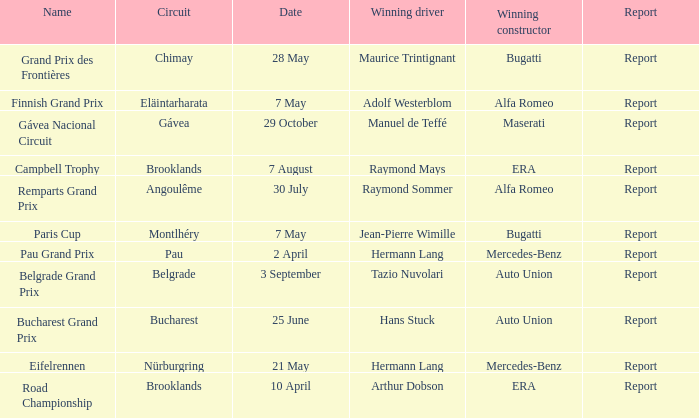Tell me the winning driver for pau grand prix Hermann Lang. 